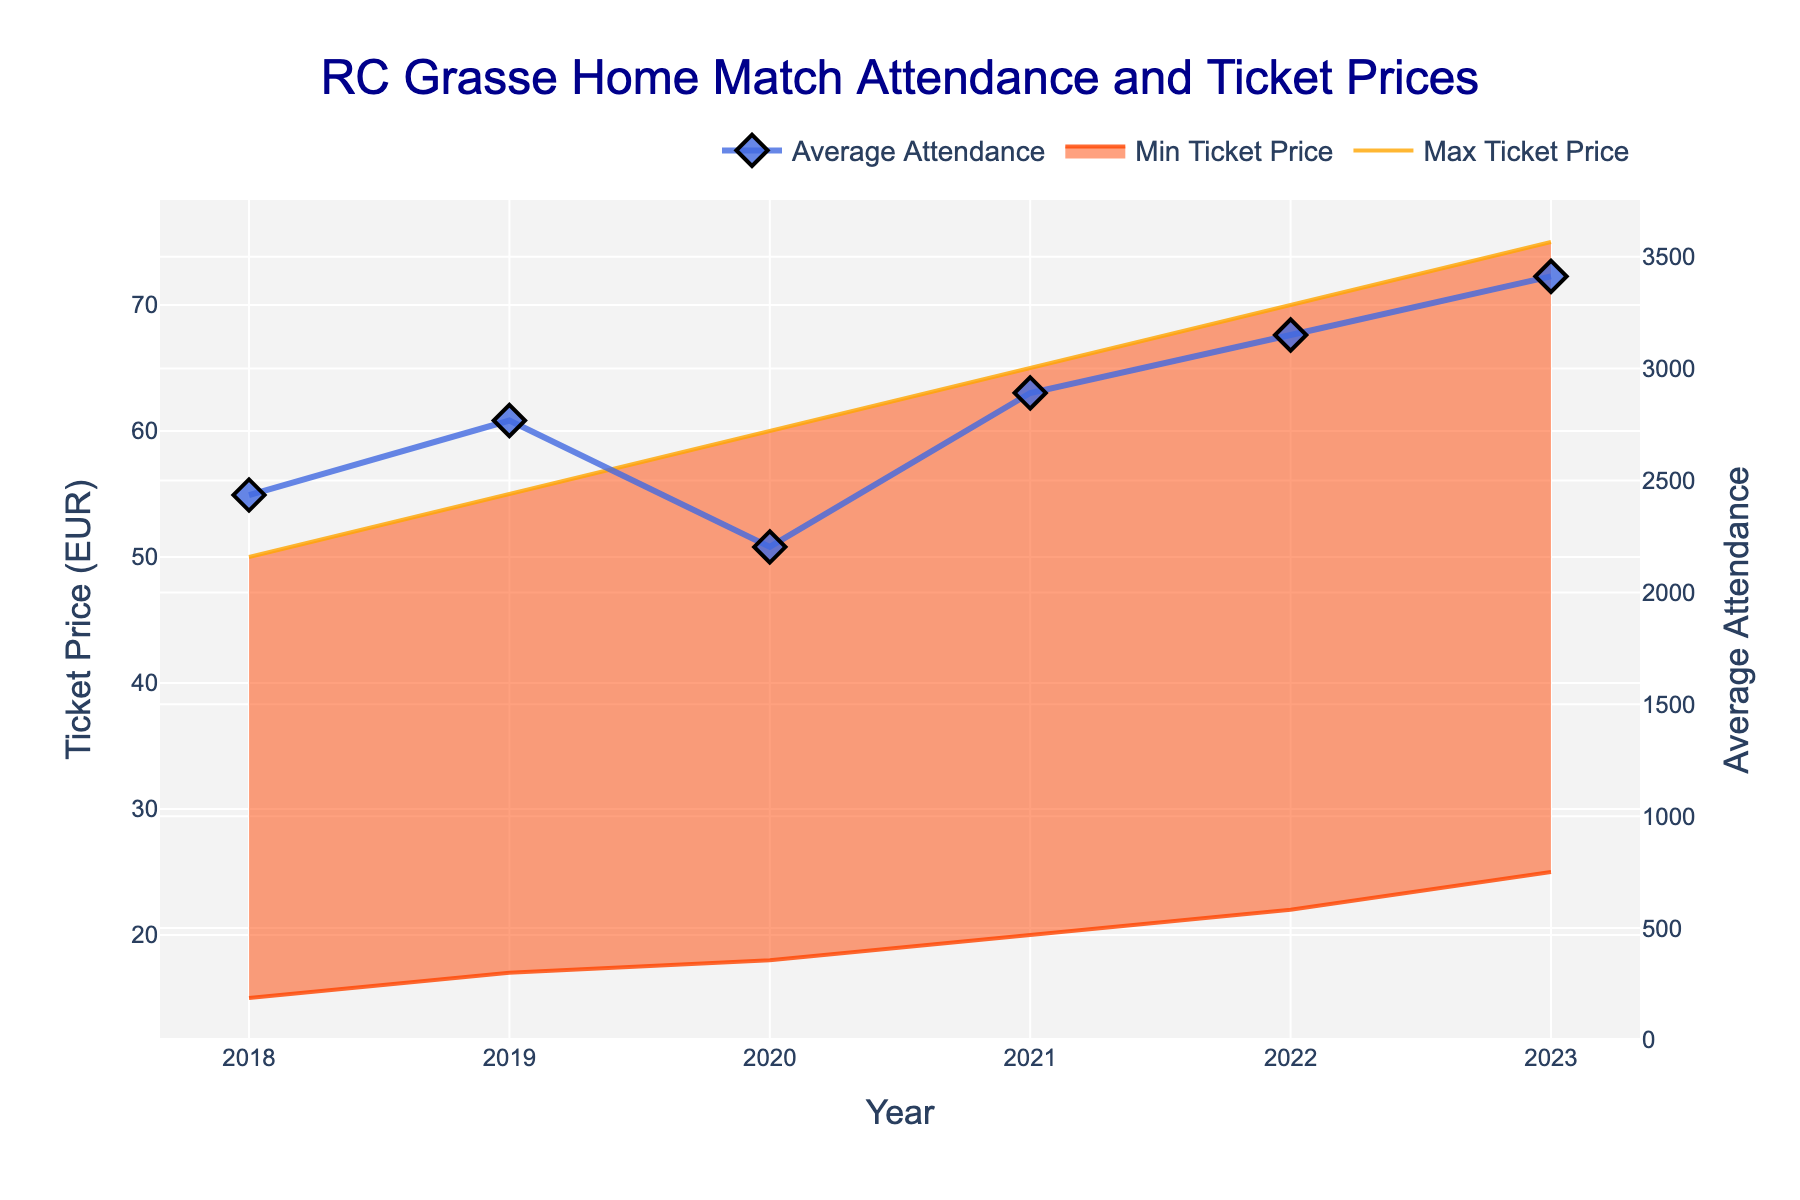How many years are displayed in the figure? The x-axis of the figure represents the years from 2018 to 2023, which counts as six distinct years.
Answer: Six years What's the title of the figure? The title of the figure is displayed prominently at the top. It reads "RC Grasse Home Match Attendance and Ticket Prices".
Answer: RC Grasse Home Match Attendance and Ticket Prices What is the maximum ticket price in 2022? The orange line labeled "Max Ticket Price" on the plot shows that the maximum ticket price in 2022 is EUR 70.
Answer: EUR 70 What is the average attendance in 2020? The blue line with diamond markers labeled "Average Attendance" on the plot shows that the average attendance in 2020 is 2203.
Answer: 2203 Did the average attendance increase or decrease between 2018 and 2023? By comparing the values of 2018 (2435) and 2023 (3412) on the blue line labeled "Average Attendance," it is visible that the attendance increased.
Answer: Increased Which year had the lowest minimum ticket price, and what was it? The red line labeled "Min Ticket Price" indicates that in 2018, the minimum ticket price was EUR 15.
Answer: 2018, EUR 15 What was the difference between the maximum and minimum ticket prices in 2021? In 2021, the maximum ticket price is EUR 65 and the minimum is EUR 20. The difference is 65 - 20 = 45.
Answer: EUR 45 How did the gap between the maximum and minimum ticket prices change from 2018 to 2023? In 2018, the gap is 50 - 15 = 35 EUR. In 2023, the gap is 75 - 25 = 50 EUR. The gap increased by 50 - 35 = 15 EUR.
Answer: Increased by EUR 15 In which year did the average attendance surpass 3000? Examining the blue line, the average attendance first surpasses 3000 in the year 2022.
Answer: 2022 What is the trend in ticket prices over the years? Both the maximum and minimum ticket prices show an increasing trend from 2018 to 2023. This can be observed by the upward slope of the orange and red lines.
Answer: Increasing 